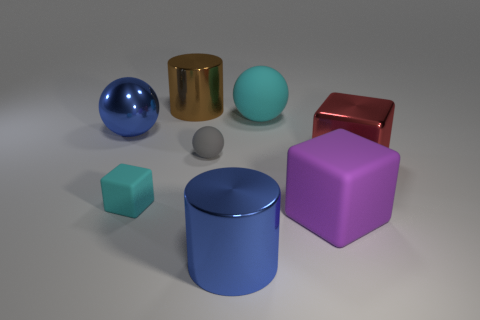There is another ball that is the same size as the cyan ball; what is its color?
Provide a succinct answer. Blue. There is a rubber thing that is behind the tiny rubber block and in front of the big cyan ball; what shape is it?
Ensure brevity in your answer.  Sphere. What is the size of the blue metallic thing that is to the left of the large metal cylinder that is on the left side of the big blue cylinder?
Your answer should be very brief. Large. How many things are the same color as the large shiny ball?
Make the answer very short. 1. How many other objects are there of the same size as the cyan ball?
Make the answer very short. 5. There is a cube that is both on the right side of the brown thing and on the left side of the red shiny thing; what is its size?
Your response must be concise. Large. What number of tiny brown metal things are the same shape as the tiny cyan matte object?
Your answer should be very brief. 0. What is the big blue cylinder made of?
Offer a terse response. Metal. Does the big brown object have the same shape as the big purple object?
Make the answer very short. No. Is there a tiny gray sphere that has the same material as the red block?
Your response must be concise. No. 